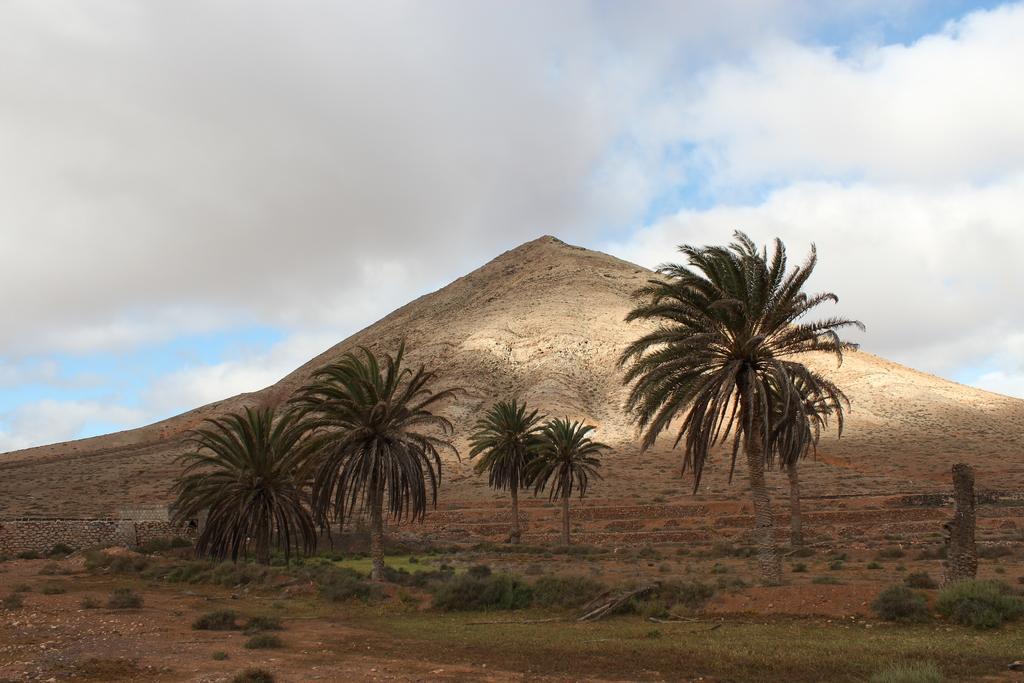How would you summarize this image in a sentence or two? In this image there are few trees, plants, stones, grass, a mountain, stone wall and some clouds in the sky. 